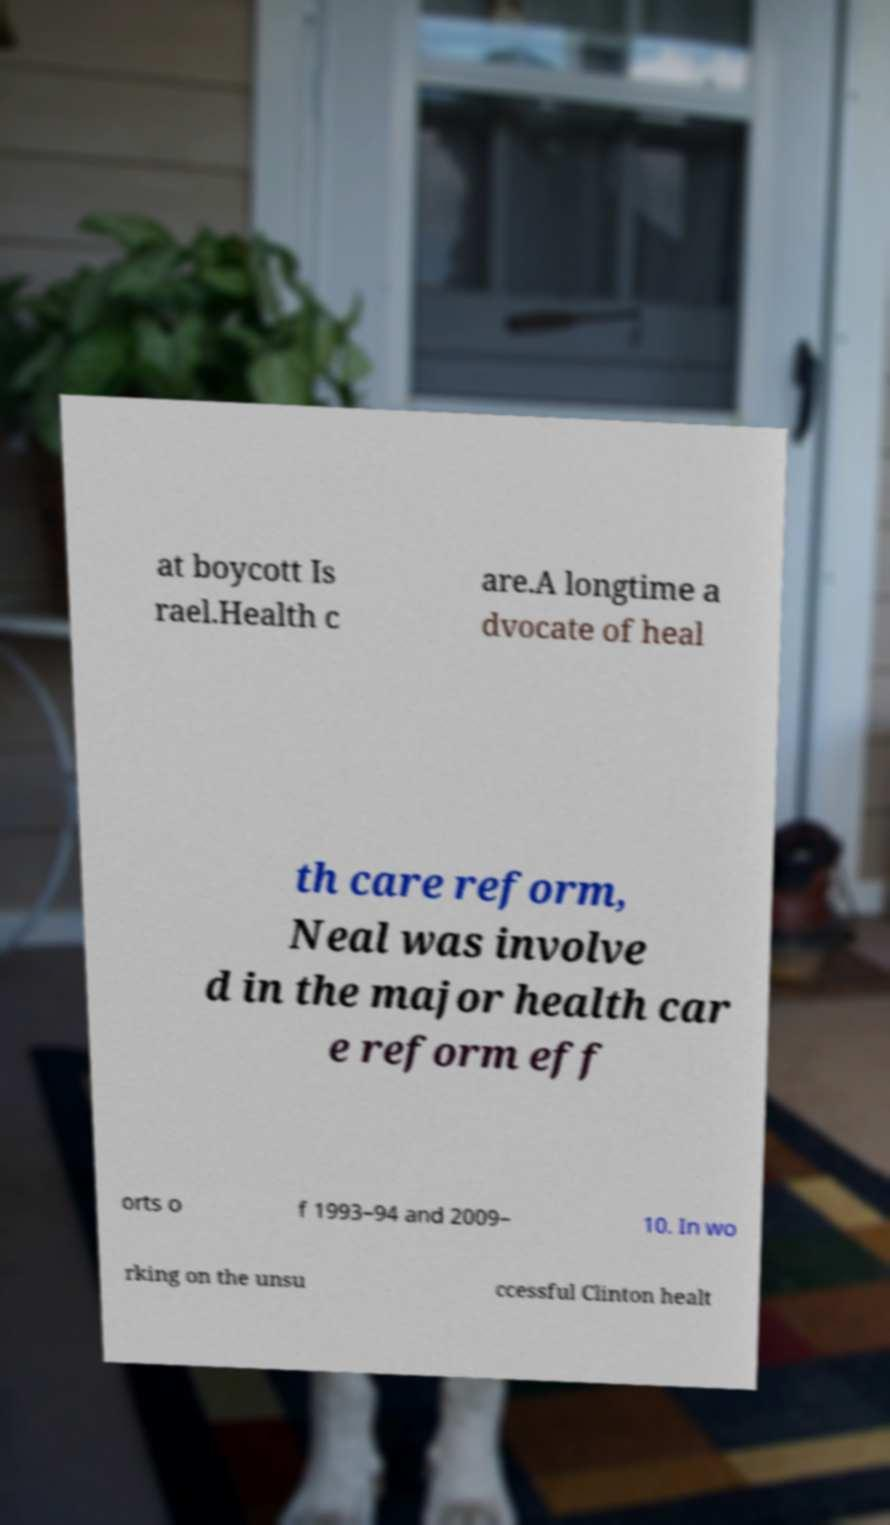Please identify and transcribe the text found in this image. at boycott Is rael.Health c are.A longtime a dvocate of heal th care reform, Neal was involve d in the major health car e reform eff orts o f 1993–94 and 2009– 10. In wo rking on the unsu ccessful Clinton healt 